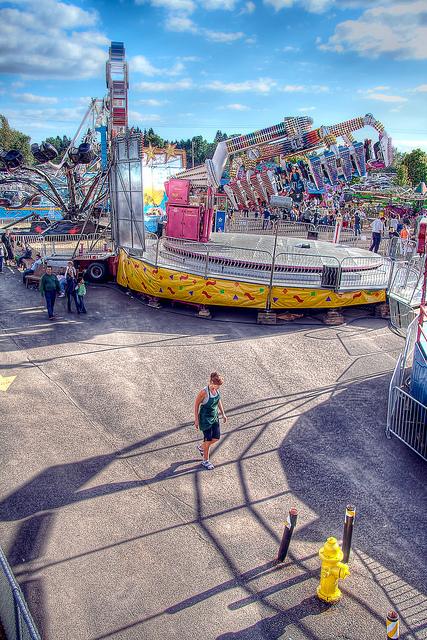Is this a place where you have fun?
Keep it brief. Yes. Is that a carnival ride in the background?
Answer briefly. Yes. Where is the fire hydrant?
Write a very short answer. Behind yellow posts. 